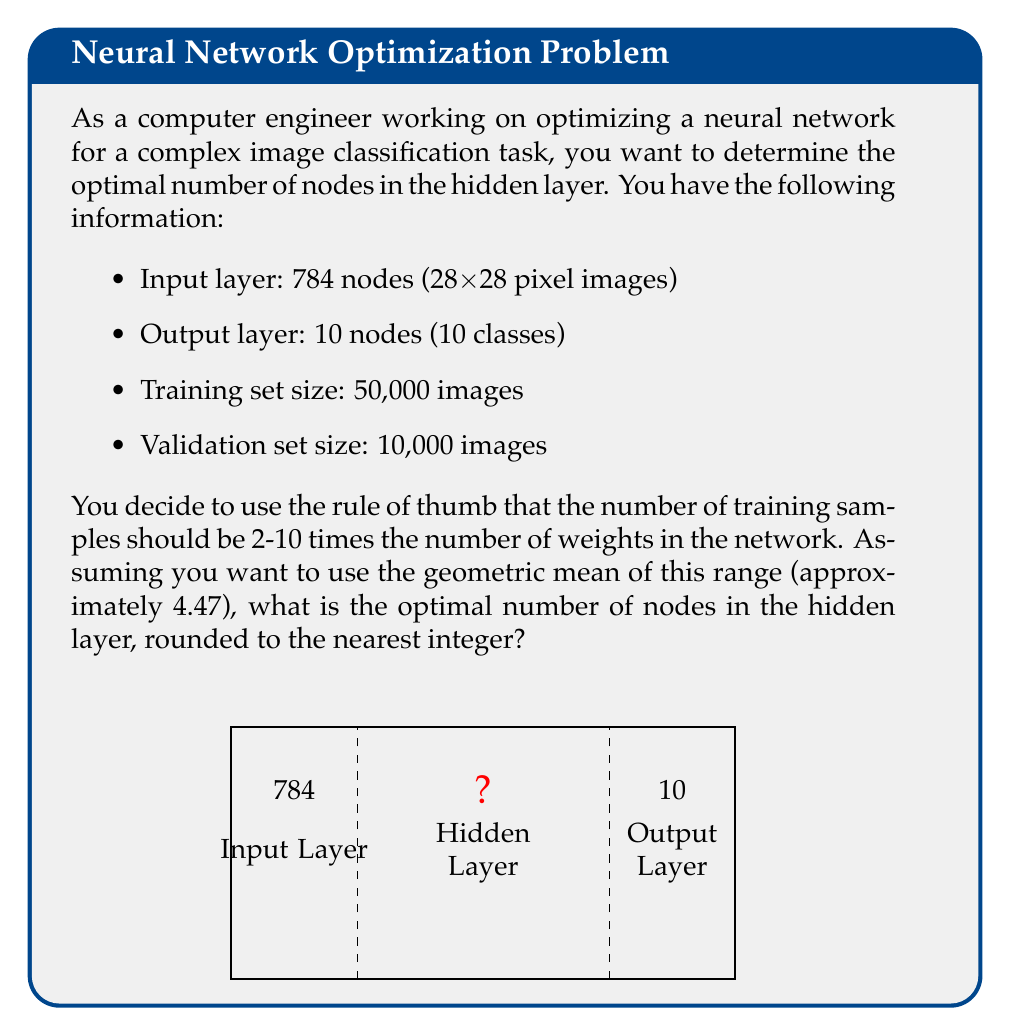Can you answer this question? Let's approach this step-by-step:

1) Let $x$ be the number of nodes in the hidden layer.

2) The number of weights in the network is:
   $$(784 \times x) + (x \times 10) + x + 10 = 794x + 10$$
   This includes weights between input and hidden layer, hidden and output layer, and biases for hidden and output layers.

3) According to the rule of thumb, we want:
   $$50,000 \approx 4.47 \times (794x + 10)$$

4) Solving for $x$:
   $$50,000 \approx 3548.78x + 44.7$$
   $$49,955.3 \approx 3548.78x$$
   $$x \approx 14.08$$

5) Rounding to the nearest integer gives us 14.

6) Let's verify:
   With 14 nodes, we have $794 \times 14 + 10 = 11,126$ weights.
   $50,000 / 11,126 \approx 4.49$, which is very close to our target of 4.47.
Answer: 14 nodes 